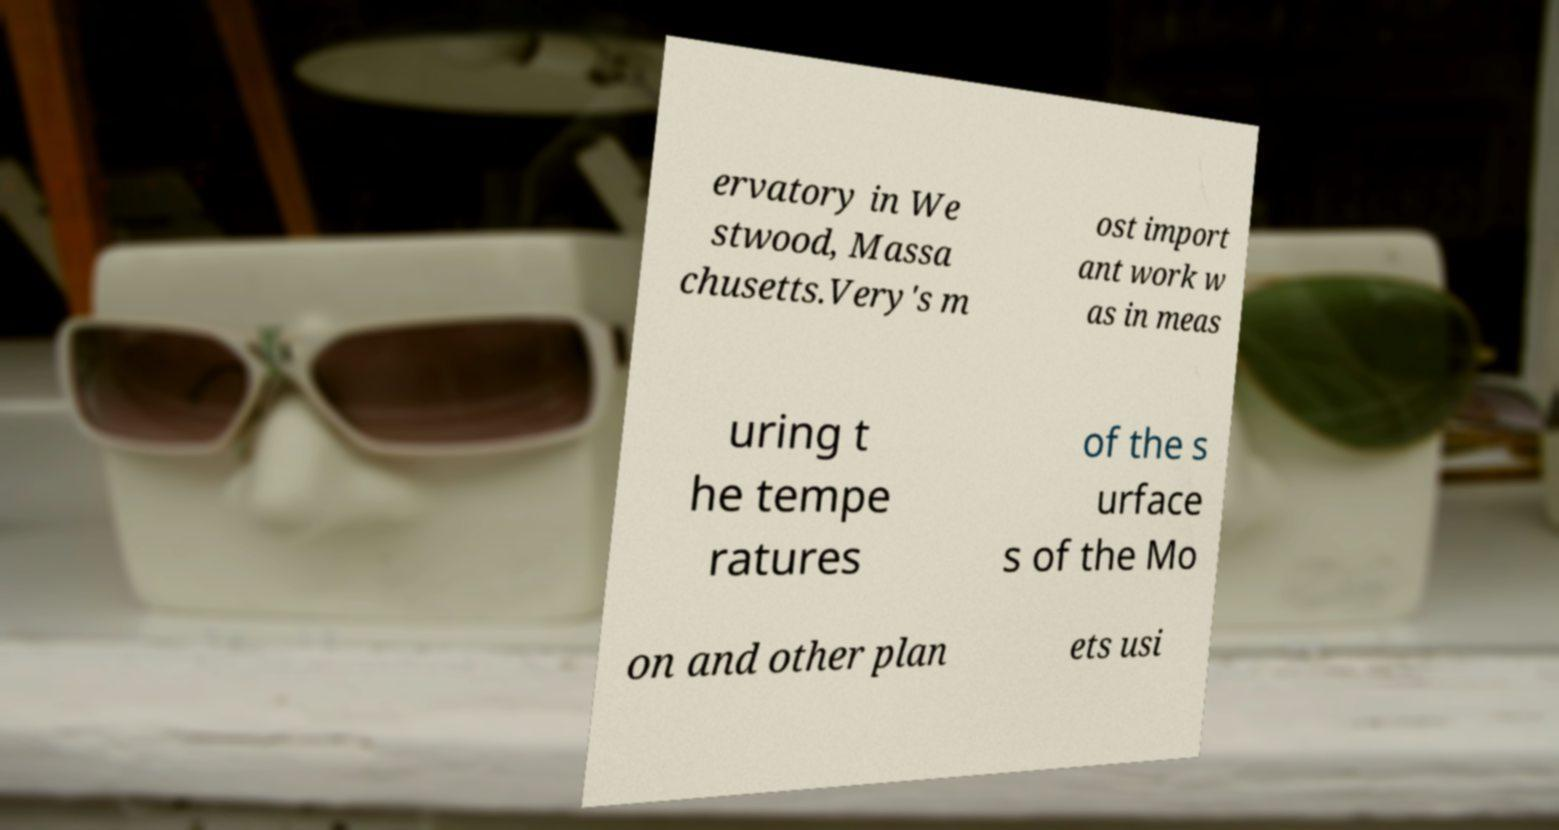I need the written content from this picture converted into text. Can you do that? ervatory in We stwood, Massa chusetts.Very's m ost import ant work w as in meas uring t he tempe ratures of the s urface s of the Mo on and other plan ets usi 